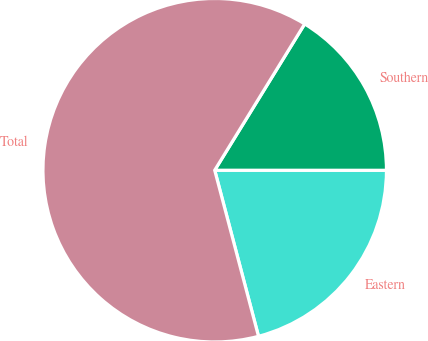<chart> <loc_0><loc_0><loc_500><loc_500><pie_chart><fcel>Eastern<fcel>Southern<fcel>Total<nl><fcel>20.89%<fcel>16.23%<fcel>62.88%<nl></chart> 